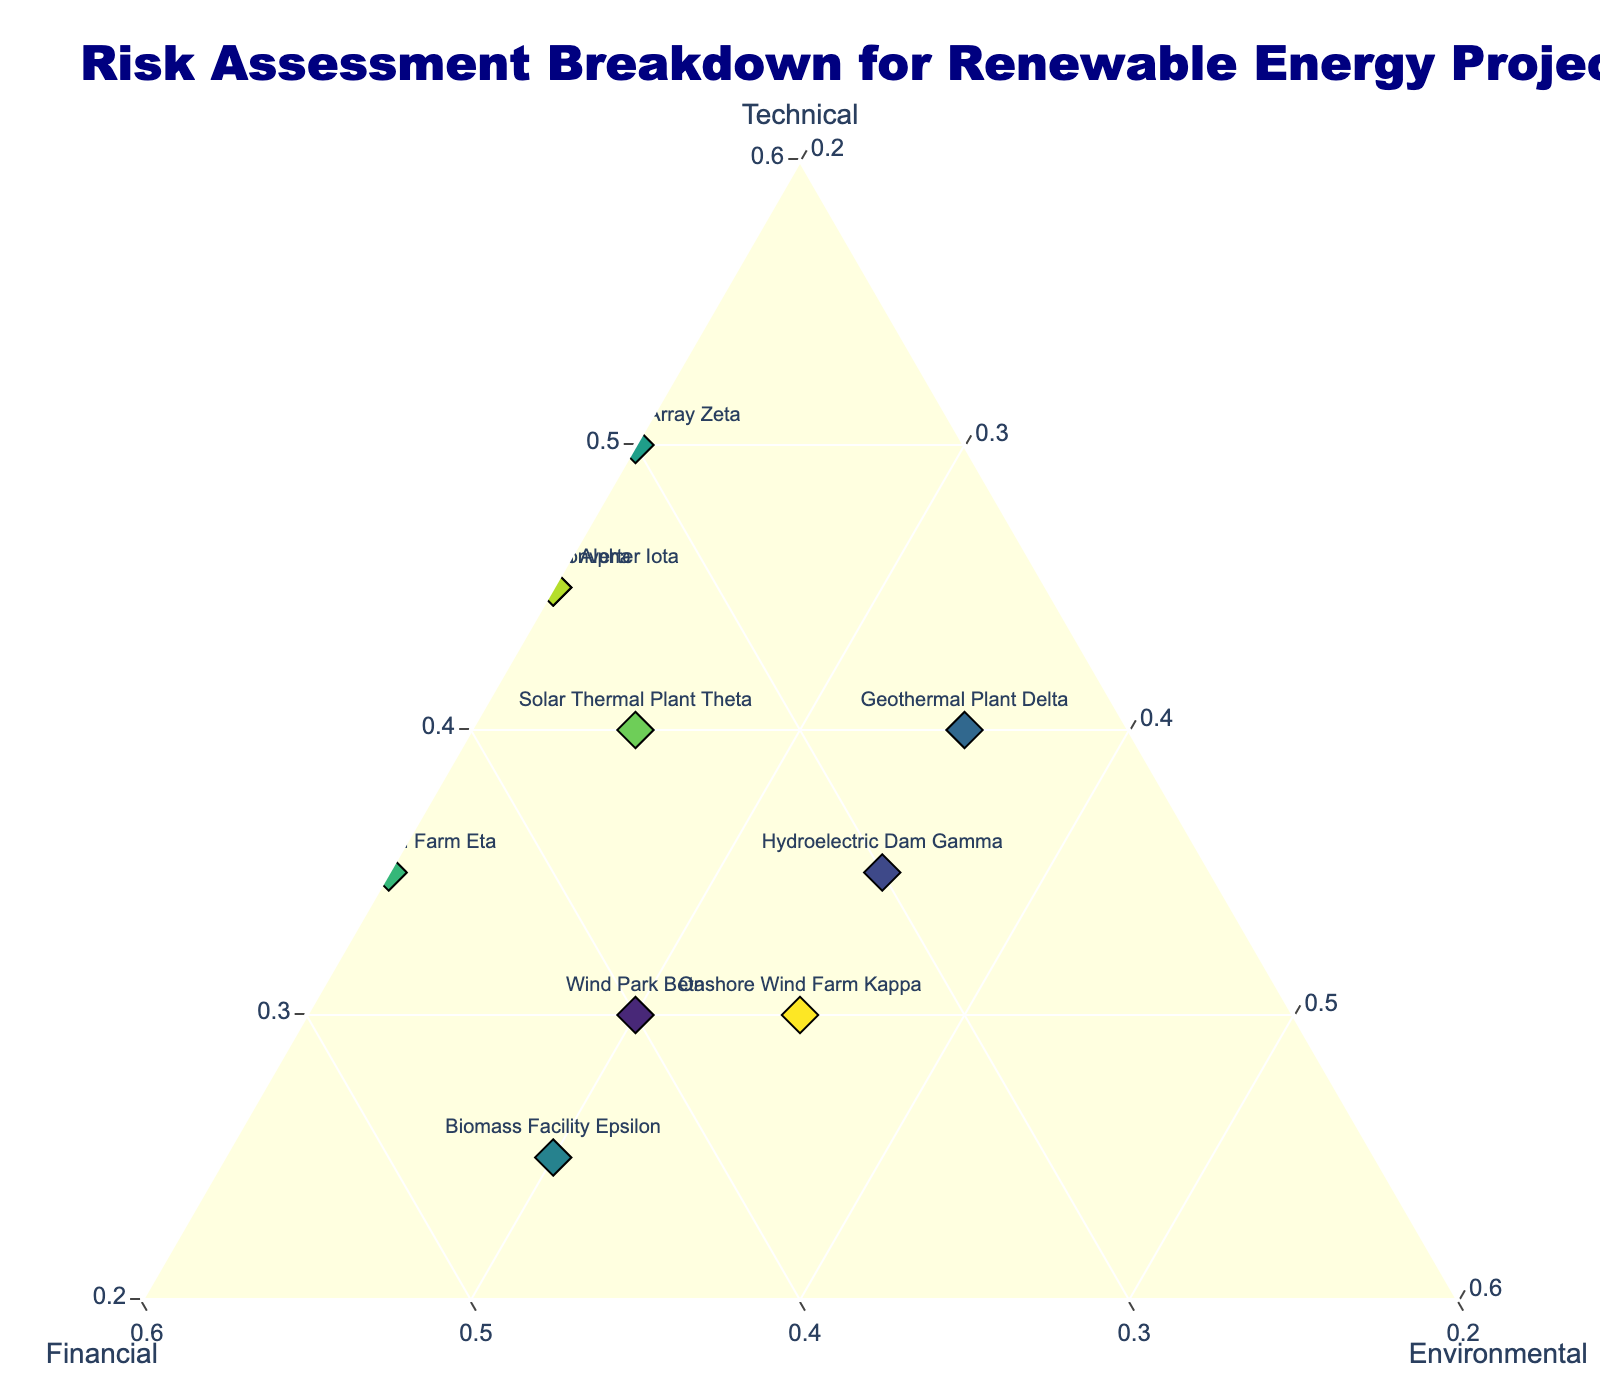What are the three primary factors assessed in this risk breakdown? The title of the ternary plot indicates that the assessment includes three factors: Technical, Financial, and Environmental. These are also labeled on the axes of the plot.
Answer: Technical, Financial, Environmental Which project has the highest Technical risk component? By looking at the point placed furthest on the Technical axis, we see that Tidal Energy Array Zeta is located at 0.50, making it the highest.
Answer: Tidal Energy Array Zeta Which projects have an equal distribution among the three risk factors? We look for points as close to the center as possible, where each factor should be roughly equal. Hydroelectric Dam Gamma (0.35, 0.30, 0.35) and Onshore Wind Farm Kappa (0.30, 0.35, 0.35) meet this criterion.
Answer: Hydroelectric Dam Gamma, Onshore Wind Farm Kappa Which project carries the most Financial risk? Looking at the Financial axis, we identify the point closest to the Financial apex. Biomass Facility Epsilon has 0.45, the highest value.
Answer: Biomass Facility Epsilon What combination of risk factors is the most balanced in the projects shown? We identify points equidistant from all axes. Hydroelectric Dam Gamma and Onshore Wind Farm Kappa are the most balanced, as their risk components are almost equal (0.35, 0.30, 0.35) and (0.30, 0.35, 0.35).
Answer: Hydroelectric Dam Gamma, Onshore Wind Farm Kappa Which projects have exactly the same risk profile? We search for overlapping points or points with identical coordinates. Solar Farm Alpha (0.45, 0.35, 0.20) and Wave Energy Converter Iota (0.45, 0.35, 0.20) have the same values.
Answer: Solar Farm Alpha, Wave Energy Converter Iota How does the risk profile of Solar Farm Alpha compare to Tidal Energy Array Zeta? Both have similar Environmental and Financial risks at 0.20 and 0.35/0.30, respectively. However, Tidal Energy Array Zeta has a higher Technical risk at 0.50 compared to Solar Farm Alpha's 0.45.
Answer: Tidal Energy Array Zeta has higher Technical risk; Environmental is the same; Financial is slightly lower What is the combined risk of the Financial and Environmental factors for Offshore Wind Farm Eta? Adding Offshore Wind Farm Eta's Financial (0.45) and Environmental (0.20) values gives us 0.45 + 0.20 = 0.65.
Answer: 0.65 Which factor contributes the least to Geothermal Plant Delta's risk profile? By comparing values, the Financial risk is 0.25, the lowest among its three factors (Technical 0.40, Environmental 0.35).
Answer: Financial What percentage of the total risk for Biomass Facility Epsilon does the Technical factor represent? The total risk sum is 1.00. The Technical risk for Biomass Facility Epsilon is 0.25. Calculating the percentage: (0.25 / 1.00) * 100 = 25%.
Answer: 25% 